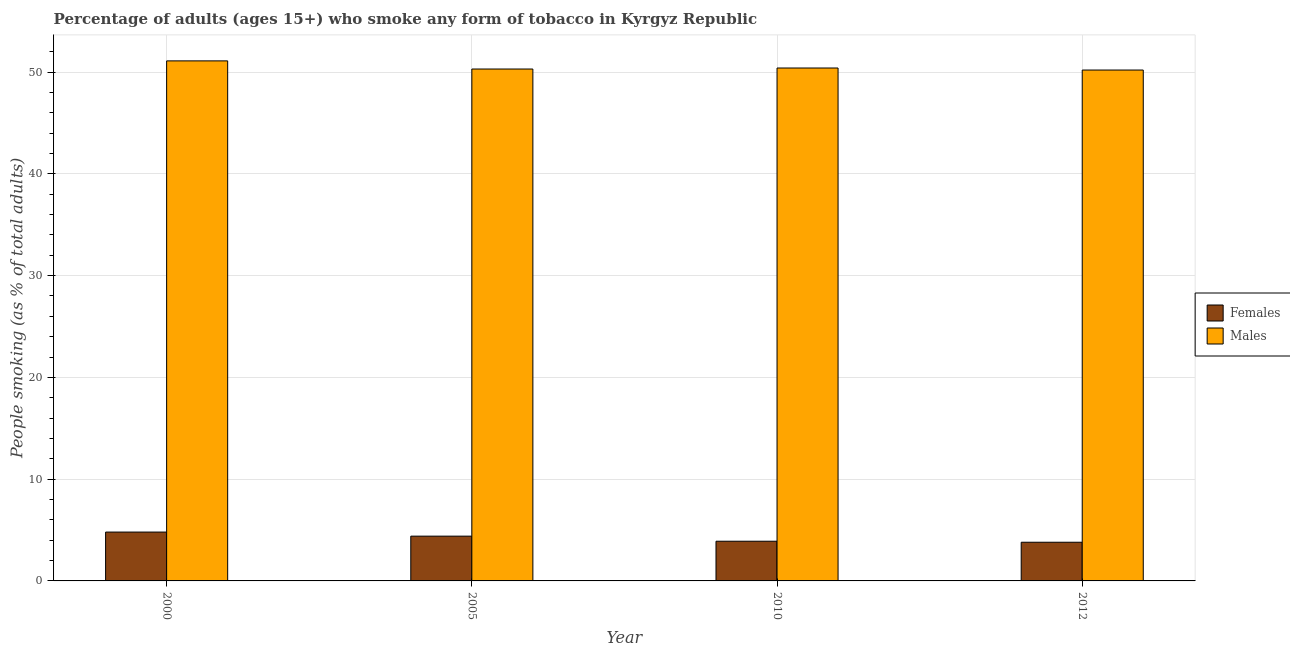How many different coloured bars are there?
Your response must be concise. 2. Are the number of bars per tick equal to the number of legend labels?
Offer a very short reply. Yes. What is the label of the 1st group of bars from the left?
Offer a very short reply. 2000. What is the percentage of males who smoke in 2000?
Provide a short and direct response. 51.1. Across all years, what is the maximum percentage of females who smoke?
Provide a succinct answer. 4.8. Across all years, what is the minimum percentage of males who smoke?
Provide a succinct answer. 50.2. In which year was the percentage of females who smoke minimum?
Give a very brief answer. 2012. What is the difference between the percentage of males who smoke in 2000 and that in 2005?
Your answer should be compact. 0.8. What is the difference between the percentage of males who smoke in 2005 and the percentage of females who smoke in 2010?
Give a very brief answer. -0.1. What is the average percentage of females who smoke per year?
Your response must be concise. 4.22. What is the ratio of the percentage of females who smoke in 2010 to that in 2012?
Your answer should be very brief. 1.03. What is the difference between the highest and the second highest percentage of males who smoke?
Provide a short and direct response. 0.7. What is the difference between the highest and the lowest percentage of males who smoke?
Make the answer very short. 0.9. Is the sum of the percentage of males who smoke in 2005 and 2012 greater than the maximum percentage of females who smoke across all years?
Keep it short and to the point. Yes. What does the 1st bar from the left in 2010 represents?
Make the answer very short. Females. What does the 2nd bar from the right in 2010 represents?
Your answer should be very brief. Females. How many bars are there?
Your answer should be very brief. 8. What is the difference between two consecutive major ticks on the Y-axis?
Ensure brevity in your answer.  10. Are the values on the major ticks of Y-axis written in scientific E-notation?
Offer a terse response. No. Does the graph contain any zero values?
Your response must be concise. No. How many legend labels are there?
Keep it short and to the point. 2. How are the legend labels stacked?
Your answer should be very brief. Vertical. What is the title of the graph?
Your response must be concise. Percentage of adults (ages 15+) who smoke any form of tobacco in Kyrgyz Republic. What is the label or title of the Y-axis?
Keep it short and to the point. People smoking (as % of total adults). What is the People smoking (as % of total adults) of Males in 2000?
Offer a very short reply. 51.1. What is the People smoking (as % of total adults) in Males in 2005?
Provide a short and direct response. 50.3. What is the People smoking (as % of total adults) in Females in 2010?
Your answer should be compact. 3.9. What is the People smoking (as % of total adults) of Males in 2010?
Offer a terse response. 50.4. What is the People smoking (as % of total adults) in Females in 2012?
Offer a very short reply. 3.8. What is the People smoking (as % of total adults) in Males in 2012?
Keep it short and to the point. 50.2. Across all years, what is the maximum People smoking (as % of total adults) in Females?
Your answer should be very brief. 4.8. Across all years, what is the maximum People smoking (as % of total adults) of Males?
Ensure brevity in your answer.  51.1. Across all years, what is the minimum People smoking (as % of total adults) in Females?
Keep it short and to the point. 3.8. Across all years, what is the minimum People smoking (as % of total adults) of Males?
Your answer should be compact. 50.2. What is the total People smoking (as % of total adults) in Females in the graph?
Your response must be concise. 16.9. What is the total People smoking (as % of total adults) of Males in the graph?
Make the answer very short. 202. What is the difference between the People smoking (as % of total adults) of Females in 2000 and that in 2005?
Provide a succinct answer. 0.4. What is the difference between the People smoking (as % of total adults) in Females in 2000 and that in 2010?
Your answer should be very brief. 0.9. What is the difference between the People smoking (as % of total adults) in Females in 2000 and that in 2012?
Your answer should be very brief. 1. What is the difference between the People smoking (as % of total adults) of Males in 2000 and that in 2012?
Provide a succinct answer. 0.9. What is the difference between the People smoking (as % of total adults) in Females in 2005 and that in 2010?
Ensure brevity in your answer.  0.5. What is the difference between the People smoking (as % of total adults) in Females in 2005 and that in 2012?
Make the answer very short. 0.6. What is the difference between the People smoking (as % of total adults) of Males in 2005 and that in 2012?
Provide a succinct answer. 0.1. What is the difference between the People smoking (as % of total adults) of Females in 2000 and the People smoking (as % of total adults) of Males in 2005?
Provide a short and direct response. -45.5. What is the difference between the People smoking (as % of total adults) of Females in 2000 and the People smoking (as % of total adults) of Males in 2010?
Provide a succinct answer. -45.6. What is the difference between the People smoking (as % of total adults) of Females in 2000 and the People smoking (as % of total adults) of Males in 2012?
Provide a succinct answer. -45.4. What is the difference between the People smoking (as % of total adults) in Females in 2005 and the People smoking (as % of total adults) in Males in 2010?
Your answer should be very brief. -46. What is the difference between the People smoking (as % of total adults) of Females in 2005 and the People smoking (as % of total adults) of Males in 2012?
Offer a very short reply. -45.8. What is the difference between the People smoking (as % of total adults) of Females in 2010 and the People smoking (as % of total adults) of Males in 2012?
Give a very brief answer. -46.3. What is the average People smoking (as % of total adults) of Females per year?
Provide a succinct answer. 4.22. What is the average People smoking (as % of total adults) in Males per year?
Give a very brief answer. 50.5. In the year 2000, what is the difference between the People smoking (as % of total adults) in Females and People smoking (as % of total adults) in Males?
Ensure brevity in your answer.  -46.3. In the year 2005, what is the difference between the People smoking (as % of total adults) in Females and People smoking (as % of total adults) in Males?
Keep it short and to the point. -45.9. In the year 2010, what is the difference between the People smoking (as % of total adults) in Females and People smoking (as % of total adults) in Males?
Your answer should be compact. -46.5. In the year 2012, what is the difference between the People smoking (as % of total adults) of Females and People smoking (as % of total adults) of Males?
Provide a short and direct response. -46.4. What is the ratio of the People smoking (as % of total adults) of Males in 2000 to that in 2005?
Offer a terse response. 1.02. What is the ratio of the People smoking (as % of total adults) in Females in 2000 to that in 2010?
Offer a terse response. 1.23. What is the ratio of the People smoking (as % of total adults) in Males in 2000 to that in 2010?
Ensure brevity in your answer.  1.01. What is the ratio of the People smoking (as % of total adults) in Females in 2000 to that in 2012?
Your answer should be very brief. 1.26. What is the ratio of the People smoking (as % of total adults) in Males in 2000 to that in 2012?
Give a very brief answer. 1.02. What is the ratio of the People smoking (as % of total adults) of Females in 2005 to that in 2010?
Provide a succinct answer. 1.13. What is the ratio of the People smoking (as % of total adults) in Females in 2005 to that in 2012?
Your answer should be compact. 1.16. What is the ratio of the People smoking (as % of total adults) in Females in 2010 to that in 2012?
Your response must be concise. 1.03. What is the ratio of the People smoking (as % of total adults) in Males in 2010 to that in 2012?
Provide a short and direct response. 1. What is the difference between the highest and the lowest People smoking (as % of total adults) of Females?
Your answer should be very brief. 1. 